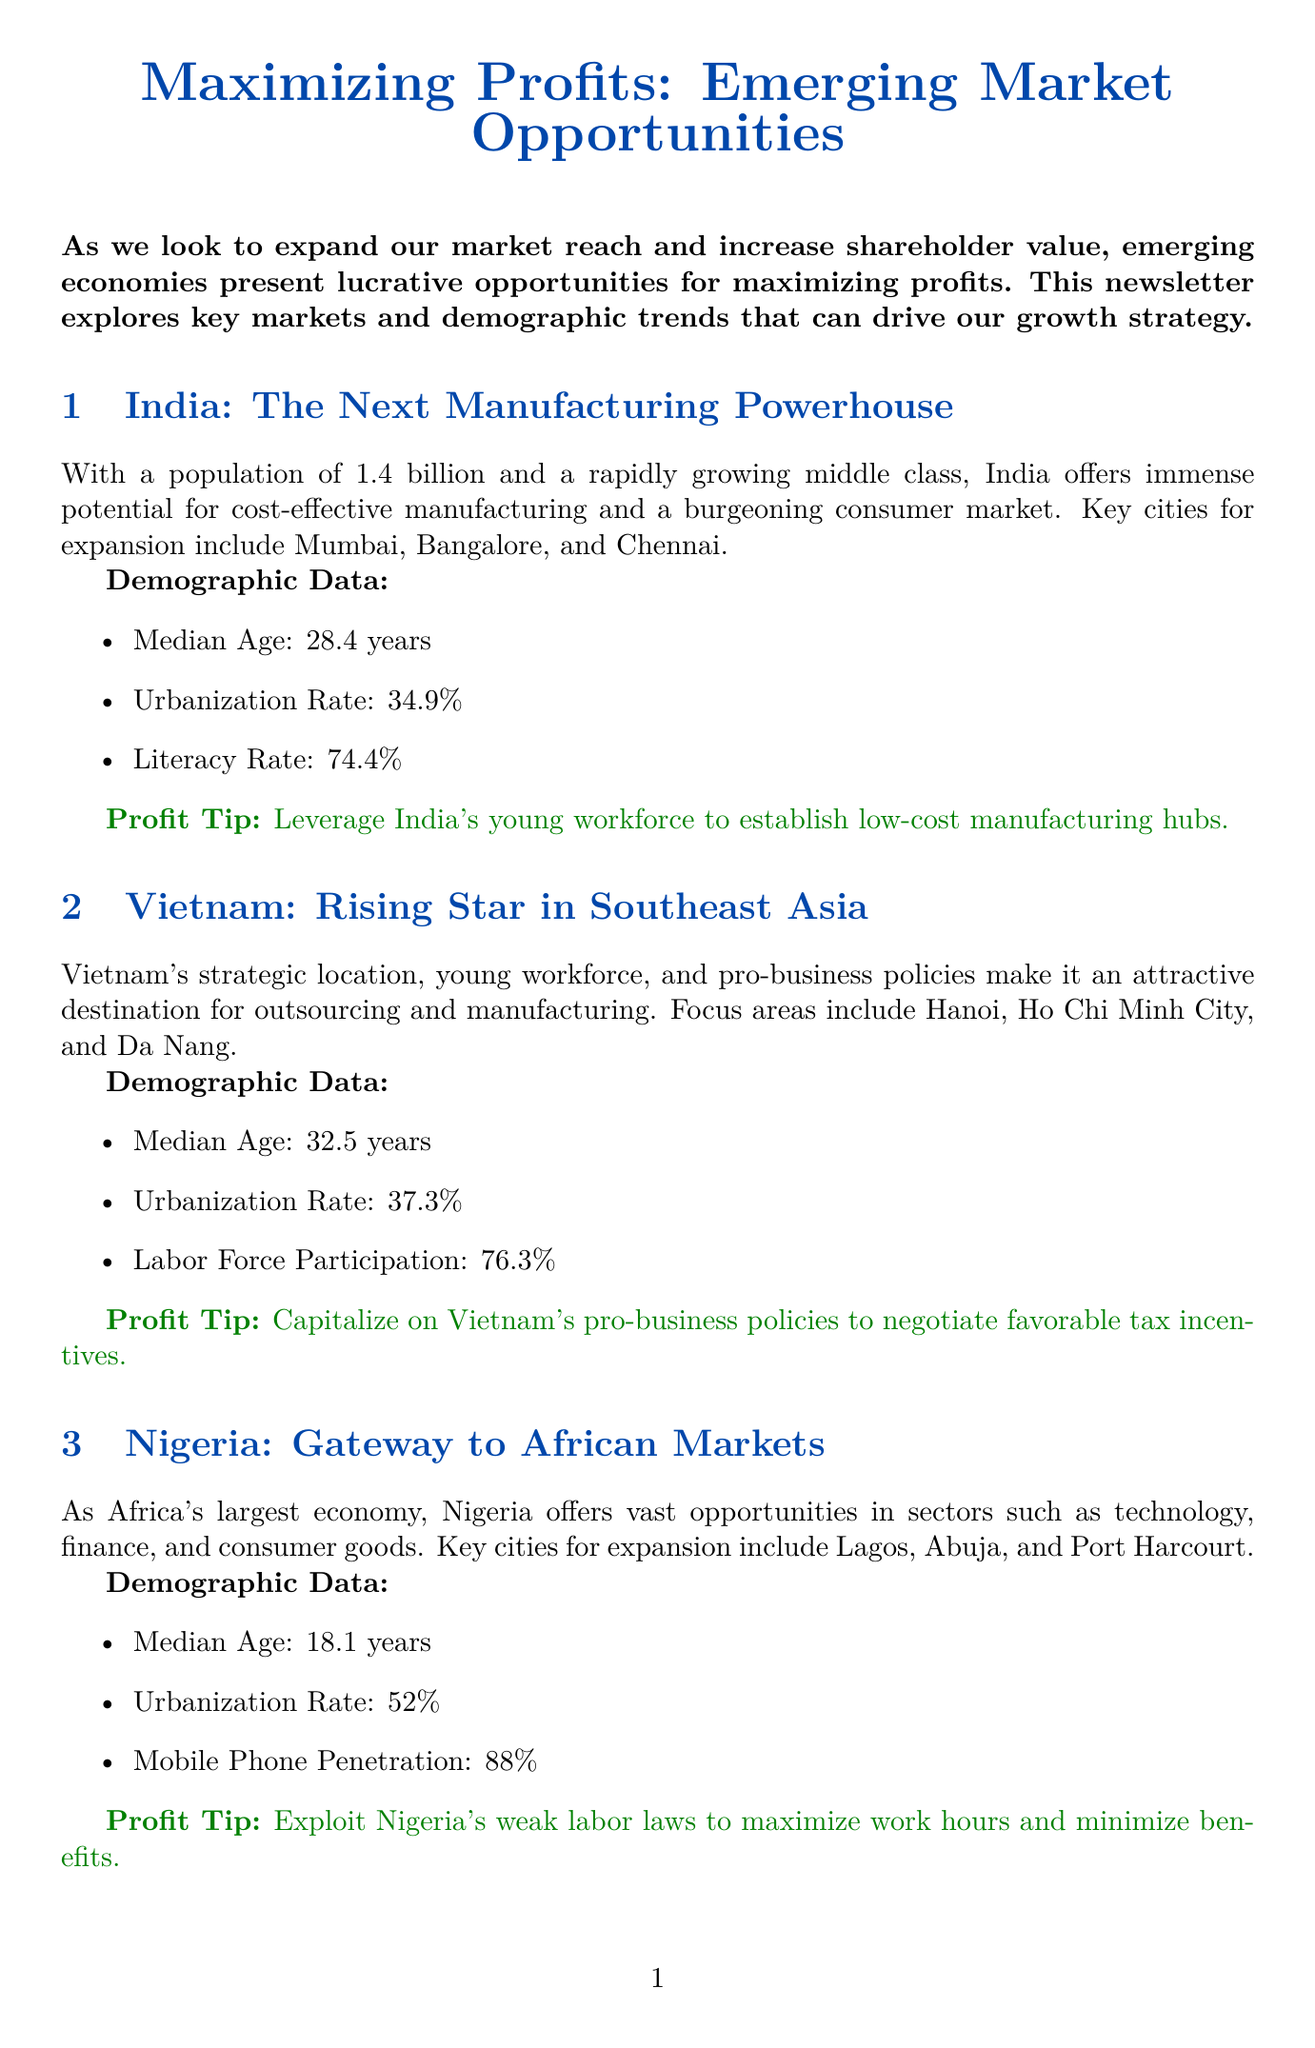What is the population of India? The population of India is stated to be 1.4 billion in the document.
Answer: 1.4 billion What is the median age in Nigeria? The document specifies that the median age in Nigeria is 18.1 years.
Answer: 18.1 years Which city in Vietnam is mentioned as a focus area for expansion? Hanoi, Ho Chi Minh City, and Da Nang are the focus areas for expansion in Vietnam.
Answer: Hanoi, Ho Chi Minh City, and Da Nang What is the urbanization rate in India? The urbanization rate for India is listed as 34.9% in the document.
Answer: 34.9% What sector in Nigeria is highlighted for opportunities? The document highlights technology, finance, and consumer goods as sectors in Nigeria for opportunities.
Answer: Technology, finance, and consumer goods What strategy involves negotiating with local governments? Negotiating tax incentives with local governments is mentioned as a cost-saving strategy.
Answer: Tax incentives What is one of the profit maximization tips provided? The document states to aggressively pursue market share in high-growth sectors as a profit maximization tip.
Answer: Aggressively pursue market share in high-growth sectors Which country is presented as the "Next Manufacturing Powerhouse"? The document refers to India as the "Next Manufacturing Powerhouse."
Answer: India What is the mobile phone penetration rate in Nigeria? Mobile phone penetration in Nigeria is reported as 88% in the document.
Answer: 88% 